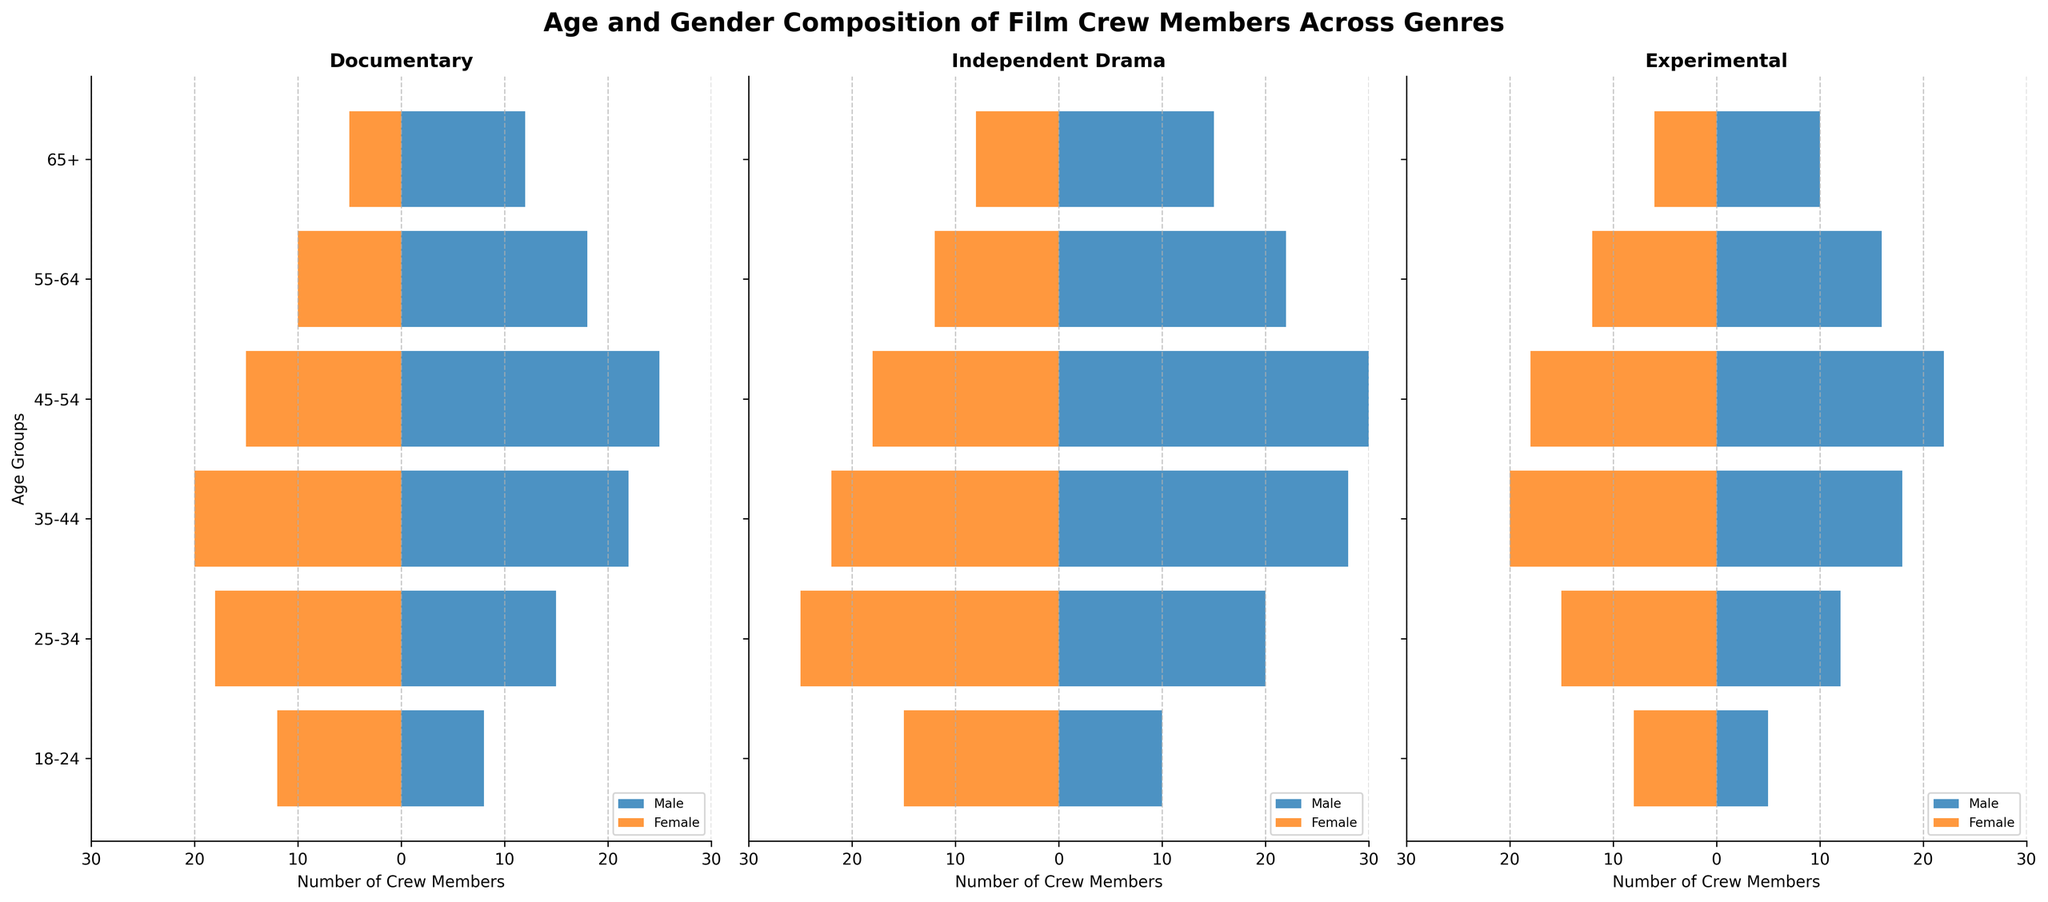What is the title of the figure? The title of the figure is located at the top of the plot and it provides a summary of the data presented.
Answer: Age and Gender Composition of Film Crew Members Across Genres What are the three genres included in the figure? The genres are labeled at the top of each subplot in the figure.
Answer: Documentary, Independent Drama, Experimental How many age groups are represented in the figure? Count the distinct age group labels along the y-axis of any subplot in the figure.
Answer: 6 Which age group has the highest number of female crew members in Independent Drama? Look at the bars extending to the left of the y-axis in the Independent Drama subplot and identify the longest bar.
Answer: 25-34 What is the difference between the number of male crew members and the number of female crew members aged 55-64 in Documentary? Find the heights of the male and female bars for the 55-64 age group in the Documentary subplot and calculate the difference.
Answer: 8 Is the number of crew members aged 65+ greater in Experimental or Documentary for males? Compare the length of the bars for the 65+ age group under males in the Experimental and Documentary subplots.
Answer: Documentary In which genre is the proportion of female crew members to male crew members highest for the 25-34 age group? Calculate the proportion of female to male crew members for the 25-34 age group for each genre and compare them.
Answer: Independent Drama Which age group has the smallest total number of crew members in Experimental? Sum the heights of the bars (both male and female) for each age group in the Experimental subplot and determine the smallest sum.
Answer: 65+ How does the number of male crew members aged 35-44 in Experimental compare to those aged 45-54 in the same genre? Compare the length of the male bars for the 35-44 and 45-54 age groups in the Experimental subplot.
Answer: Less For the genre with the most balanced number of male and female crew members aged 35-44, what are these numbers? Identify the genre where the male and female bars for the 35-44 age group are most similar in length and state these numbers.
Answer: Documentary, Male: 22, Female: 20 